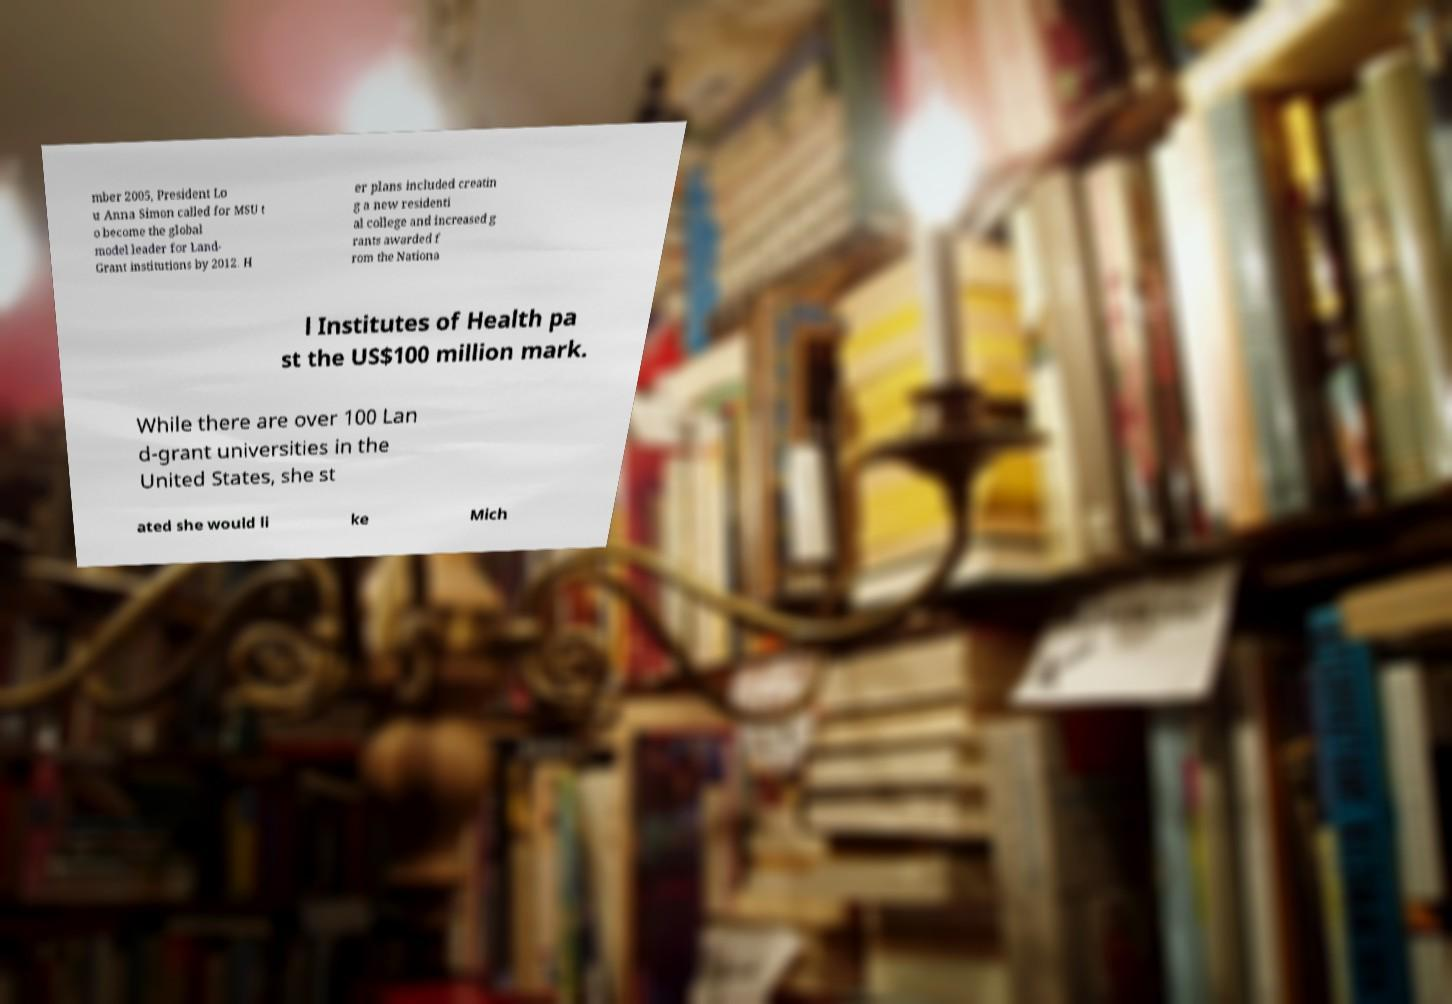Could you extract and type out the text from this image? mber 2005, President Lo u Anna Simon called for MSU t o become the global model leader for Land- Grant institutions by 2012. H er plans included creatin g a new residenti al college and increased g rants awarded f rom the Nationa l Institutes of Health pa st the US$100 million mark. While there are over 100 Lan d-grant universities in the United States, she st ated she would li ke Mich 